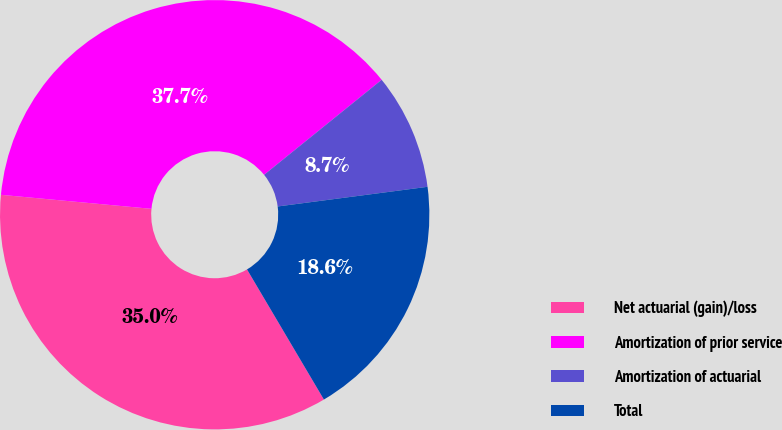Convert chart. <chart><loc_0><loc_0><loc_500><loc_500><pie_chart><fcel>Net actuarial (gain)/loss<fcel>Amortization of prior service<fcel>Amortization of actuarial<fcel>Total<nl><fcel>34.97%<fcel>37.7%<fcel>8.74%<fcel>18.58%<nl></chart> 